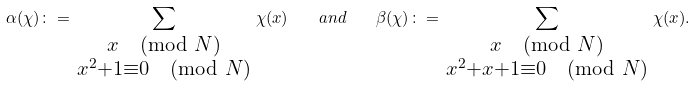<formula> <loc_0><loc_0><loc_500><loc_500>\alpha ( \chi ) \colon = \sum _ { \begin{smallmatrix} x \pmod { N } \\ x ^ { 2 } + 1 \equiv 0 \pmod { N } \end{smallmatrix} } \chi ( x ) \quad a n d \quad \beta ( \chi ) \colon = \sum _ { \begin{smallmatrix} x \pmod { N } \\ x ^ { 2 } + x + 1 \equiv 0 \pmod { N } \end{smallmatrix} } \chi ( x ) .</formula> 